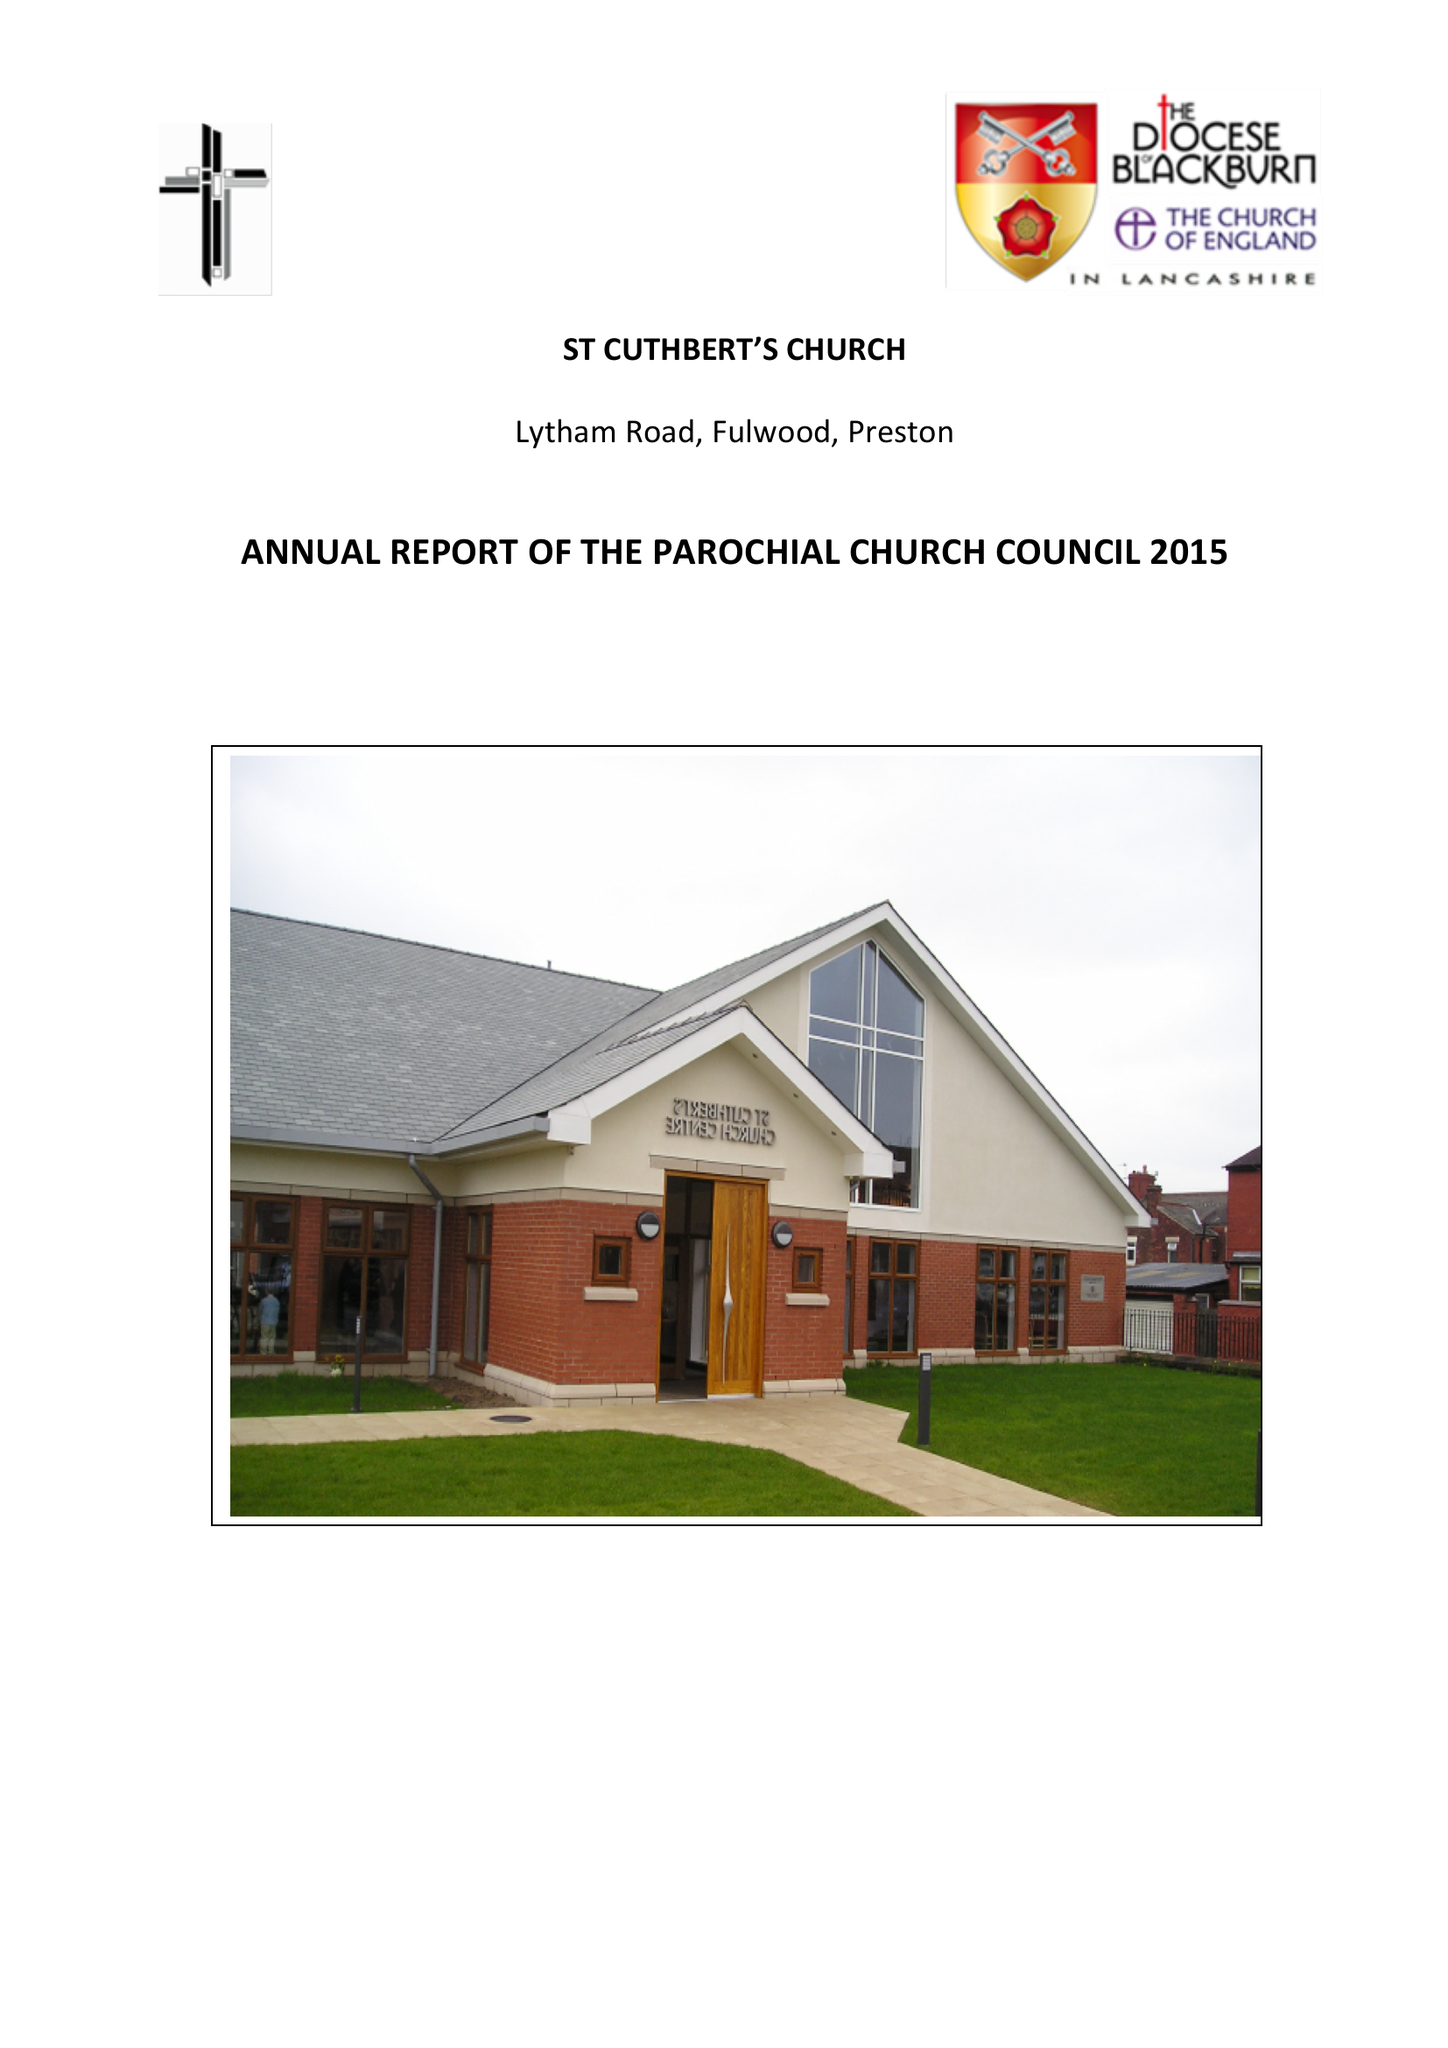What is the value for the charity_name?
Answer the question using a single word or phrase. The Parochial Church Council Of The Ecclesiastical Parish Of St Cuthberts, Fulwood 